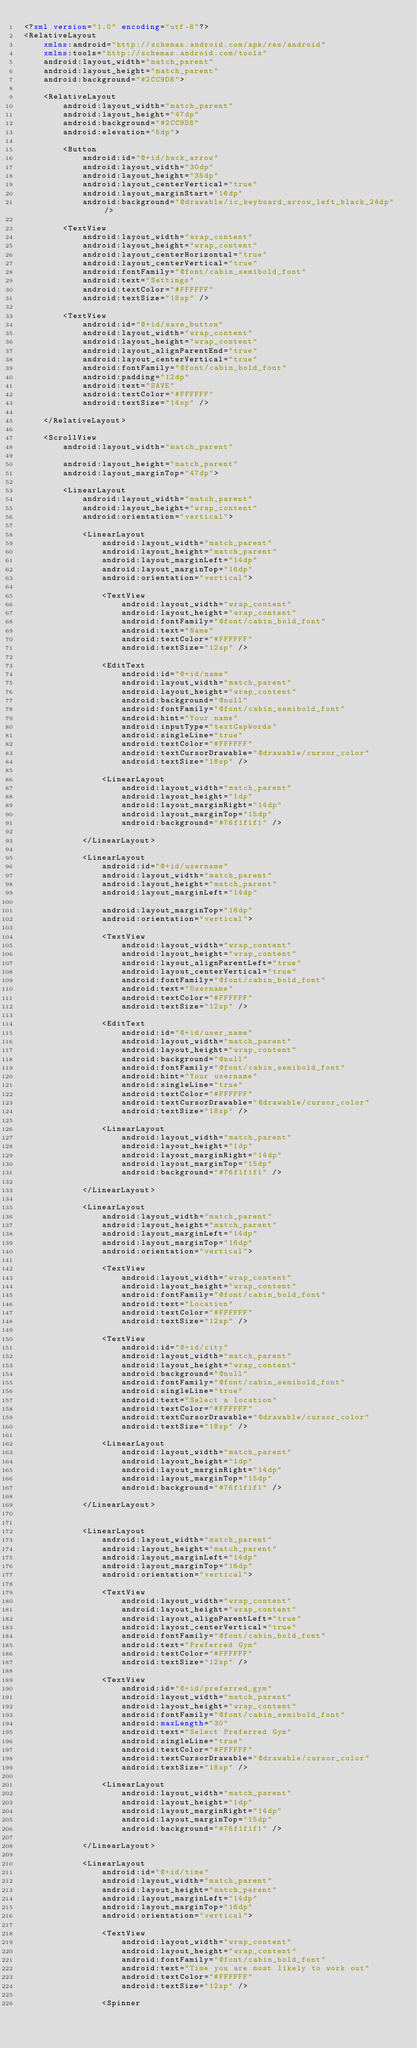<code> <loc_0><loc_0><loc_500><loc_500><_XML_><?xml version="1.0" encoding="utf-8"?>
<RelativeLayout
    xmlns:android="http://schemas.android.com/apk/res/android"
    xmlns:tools="http://schemas.android.com/tools"
    android:layout_width="match_parent"
    android:layout_height="match_parent"
    android:background="#2CC9D8">

    <RelativeLayout
        android:layout_width="match_parent"
        android:layout_height="47dp"
        android:background="#2CC9D8"
        android:elevation="5dp">

        <Button
            android:id="@+id/back_arrow"
            android:layout_width="30dp"
            android:layout_height="35dp"
            android:layout_centerVertical="true"
            android:layout_marginStart="16dp"
            android:background="@drawable/ic_keyboard_arrow_left_black_24dp" />

        <TextView
            android:layout_width="wrap_content"
            android:layout_height="wrap_content"
            android:layout_centerHorizontal="true"
            android:layout_centerVertical="true"
            android:fontFamily="@font/cabin_semibold_font"
            android:text="Settings"
            android:textColor="#FFFFFF"
            android:textSize="18sp" />

        <TextView
            android:id="@+id/save_button"
            android:layout_width="wrap_content"
            android:layout_height="wrap_content"
            android:layout_alignParentEnd="true"
            android:layout_centerVertical="true"
            android:fontFamily="@font/cabin_bold_font"
            android:padding="12dp"
            android:text="SAVE"
            android:textColor="#FFFFFF"
            android:textSize="14sp" />

    </RelativeLayout>

    <ScrollView
        android:layout_width="match_parent"

        android:layout_height="match_parent"
        android:layout_marginTop="47dp">

        <LinearLayout
            android:layout_width="match_parent"
            android:layout_height="wrap_content"
            android:orientation="vertical">

            <LinearLayout
                android:layout_width="match_parent"
                android:layout_height="match_parent"
                android:layout_marginLeft="14dp"
                android:layout_marginTop="16dp"
                android:orientation="vertical">

                <TextView
                    android:layout_width="wrap_content"
                    android:layout_height="wrap_content"
                    android:fontFamily="@font/cabin_bold_font"
                    android:text="Name"
                    android:textColor="#FFFFFF"
                    android:textSize="12sp" />

                <EditText
                    android:id="@+id/name"
                    android:layout_width="match_parent"
                    android:layout_height="wrap_content"
                    android:background="@null"
                    android:fontFamily="@font/cabin_semibold_font"
                    android:hint="Your name"
                    android:inputType="textCapWords"
                    android:singleLine="true"
                    android:textColor="#FFFFFF"
                    android:textCursorDrawable="@drawable/cursor_color"
                    android:textSize="18sp" />

                <LinearLayout
                    android:layout_width="match_parent"
                    android:layout_height="1dp"
                    android:layout_marginRight="14dp"
                    android:layout_marginTop="15dp"
                    android:background="#76f1f1f1" />

            </LinearLayout>

            <LinearLayout
                android:id="@+id/username"
                android:layout_width="match_parent"
                android:layout_height="match_parent"
                android:layout_marginLeft="14dp"

                android:layout_marginTop="16dp"
                android:orientation="vertical">

                <TextView
                    android:layout_width="wrap_content"
                    android:layout_height="wrap_content"
                    android:layout_alignParentLeft="true"
                    android:layout_centerVertical="true"
                    android:fontFamily="@font/cabin_bold_font"
                    android:text="Username"
                    android:textColor="#FFFFFF"
                    android:textSize="12sp" />

                <EditText
                    android:id="@+id/user_name"
                    android:layout_width="match_parent"
                    android:layout_height="wrap_content"
                    android:background="@null"
                    android:fontFamily="@font/cabin_semibold_font"
                    android:hint="Your username"
                    android:singleLine="true"
                    android:textColor="#FFFFFF"
                    android:textCursorDrawable="@drawable/cursor_color"
                    android:textSize="18sp" />

                <LinearLayout
                    android:layout_width="match_parent"
                    android:layout_height="1dp"
                    android:layout_marginRight="14dp"
                    android:layout_marginTop="15dp"
                    android:background="#76f1f1f1" />

            </LinearLayout>

            <LinearLayout
                android:layout_width="match_parent"
                android:layout_height="match_parent"
                android:layout_marginLeft="14dp"
                android:layout_marginTop="16dp"
                android:orientation="vertical">

                <TextView
                    android:layout_width="wrap_content"
                    android:layout_height="wrap_content"
                    android:fontFamily="@font/cabin_bold_font"
                    android:text="Location"
                    android:textColor="#FFFFFF"
                    android:textSize="12sp" />

                <TextView
                    android:id="@+id/city"
                    android:layout_width="match_parent"
                    android:layout_height="wrap_content"
                    android:background="@null"
                    android:fontFamily="@font/cabin_semibold_font"
                    android:singleLine="true"
                    android:text="Select a location"
                    android:textColor="#FFFFFF"
                    android:textCursorDrawable="@drawable/cursor_color"
                    android:textSize="18sp" />

                <LinearLayout
                    android:layout_width="match_parent"
                    android:layout_height="1dp"
                    android:layout_marginRight="14dp"
                    android:layout_marginTop="15dp"
                    android:background="#76f1f1f1" />

            </LinearLayout>


            <LinearLayout
                android:layout_width="match_parent"
                android:layout_height="match_parent"
                android:layout_marginLeft="14dp"
                android:layout_marginTop="16dp"
                android:orientation="vertical">

                <TextView
                    android:layout_width="wrap_content"
                    android:layout_height="wrap_content"
                    android:layout_alignParentLeft="true"
                    android:layout_centerVertical="true"
                    android:fontFamily="@font/cabin_bold_font"
                    android:text="Preferred Gym"
                    android:textColor="#FFFFFF"
                    android:textSize="12sp" />

                <TextView
                    android:id="@+id/preferred_gym"
                    android:layout_width="match_parent"
                    android:layout_height="wrap_content"
                    android:fontFamily="@font/cabin_semibold_font"
                    android:maxLength="30"
                    android:text="Select Preferred Gym"
                    android:singleLine="true"
                    android:textColor="#FFFFFF"
                    android:textCursorDrawable="@drawable/cursor_color"
                    android:textSize="18sp" />

                <LinearLayout
                    android:layout_width="match_parent"
                    android:layout_height="1dp"
                    android:layout_marginRight="14dp"
                    android:layout_marginTop="15dp"
                    android:background="#76f1f1f1" />

            </LinearLayout>

            <LinearLayout
                android:id="@+id/time"
                android:layout_width="match_parent"
                android:layout_height="match_parent"
                android:layout_marginLeft="14dp"
                android:layout_marginTop="16dp"
                android:orientation="vertical">

                <TextView
                    android:layout_width="wrap_content"
                    android:layout_height="wrap_content"
                    android:fontFamily="@font/cabin_bold_font"
                    android:text="Time you are most likely to work out"
                    android:textColor="#FFFFFF"
                    android:textSize="12sp" />

                <Spinner</code> 